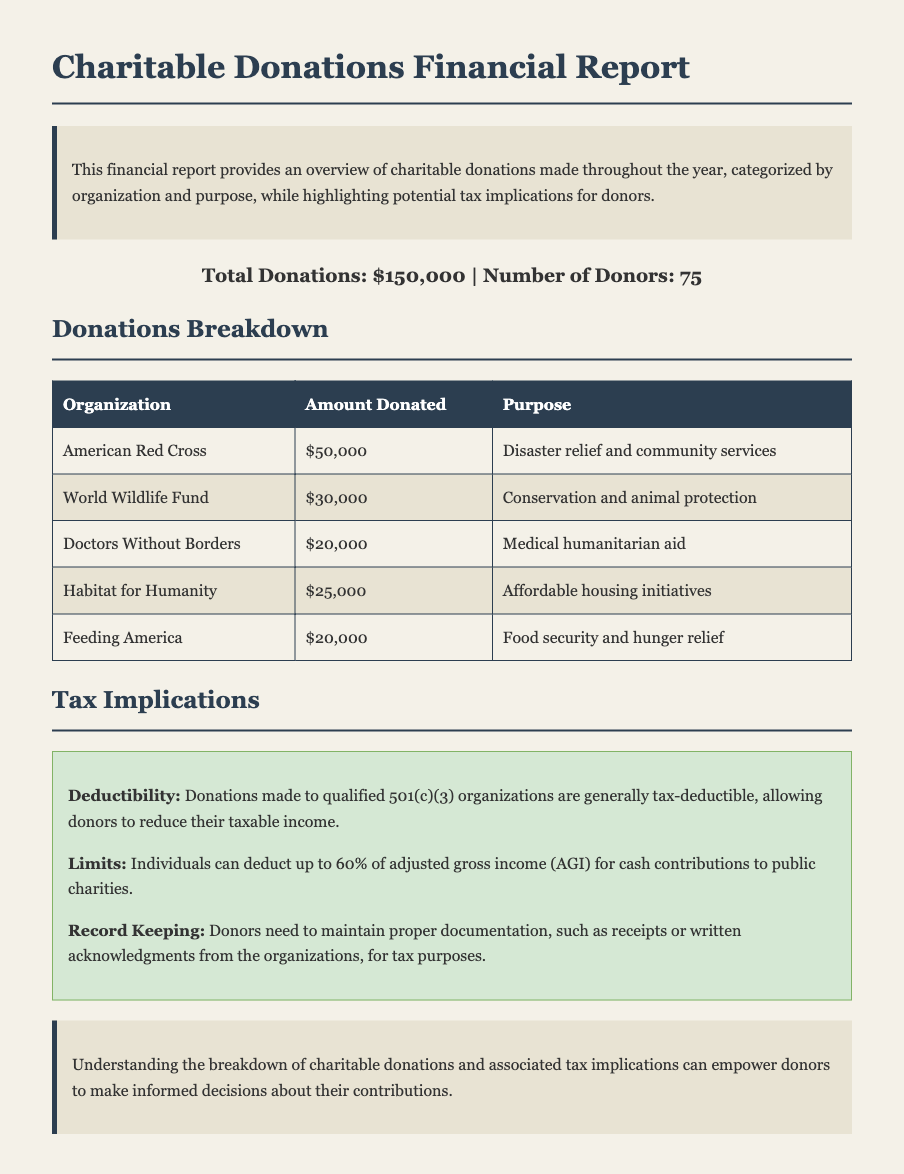What is the total amount of donations? The total amount of donations is listed at the end of the document, which sums up all contributions made throughout the year.
Answer: $150,000 How many organizations received donations? The number of organizations can be counted from the donations table, which lists each organization that received funds.
Answer: 5 What was the purpose of the donation to Doctors Without Borders? The purpose of the donation is provided in the donations table under the 'Purpose' column for Doctors Without Borders.
Answer: Medical humanitarian aid Which organization received the largest donation? The organization with the highest donation amount can be identified from the donations table.
Answer: American Red Cross What percentage of adjusted gross income can individuals deduct for cash contributions? The document specifies the limit on the percentage of AGI that can be deducted for cash contributions to public charities.
Answer: 60% What type of organizations are donations made to for tax deductibility? The document notes a specific classification of organizations that qualify for tax deductibility of donations.
Answer: 501(c)(3) What is required for proper documentation of donations? The document provides information on what donors need to maintain to fulfill tax purposes regarding their donations.
Answer: Receipts or written acknowledgments What is the total number of donors mentioned? The total number of donors is stated in the document alongside the summary of donations.
Answer: 75 